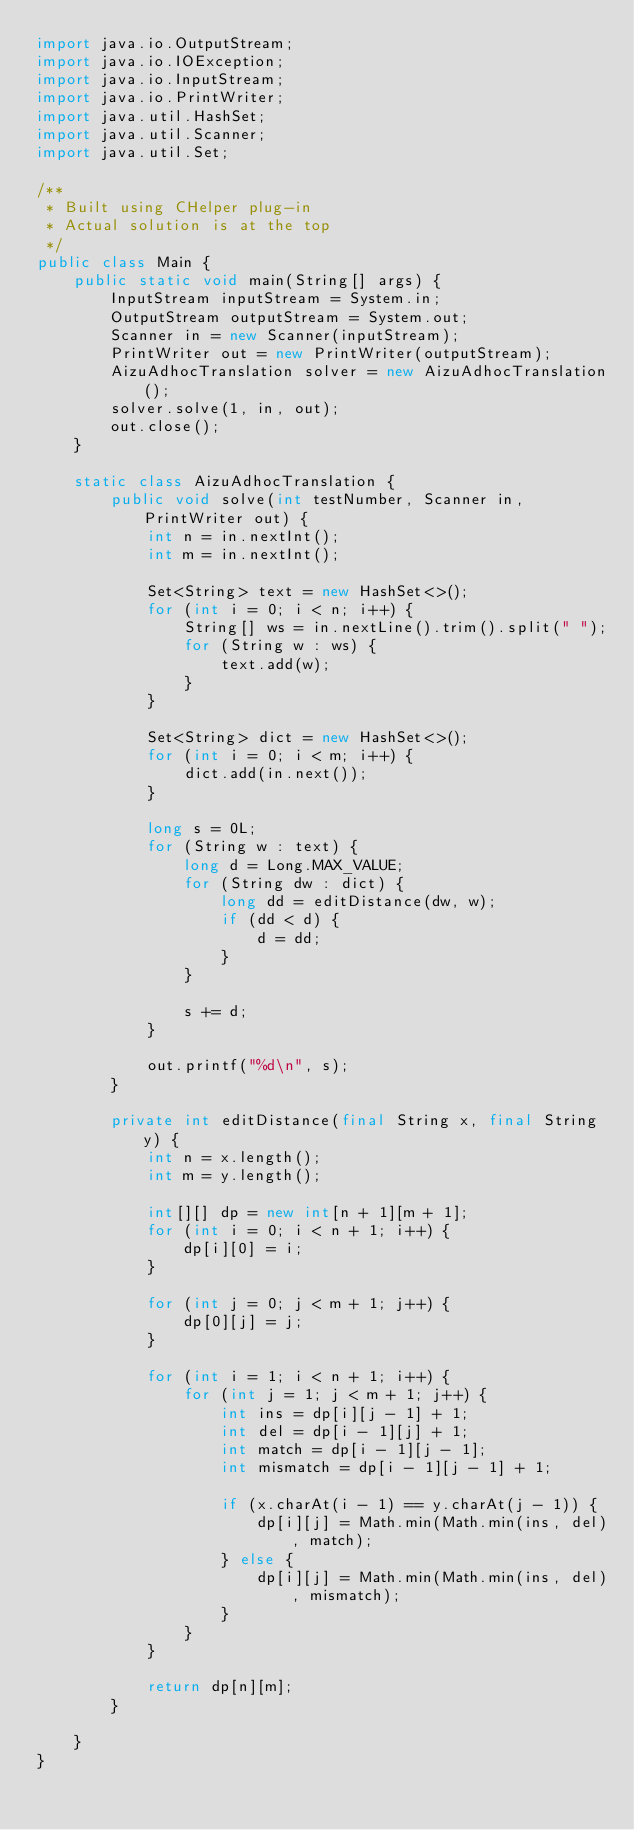Convert code to text. <code><loc_0><loc_0><loc_500><loc_500><_Java_>import java.io.OutputStream;
import java.io.IOException;
import java.io.InputStream;
import java.io.PrintWriter;
import java.util.HashSet;
import java.util.Scanner;
import java.util.Set;

/**
 * Built using CHelper plug-in
 * Actual solution is at the top
 */
public class Main {
    public static void main(String[] args) {
        InputStream inputStream = System.in;
        OutputStream outputStream = System.out;
        Scanner in = new Scanner(inputStream);
        PrintWriter out = new PrintWriter(outputStream);
        AizuAdhocTranslation solver = new AizuAdhocTranslation();
        solver.solve(1, in, out);
        out.close();
    }

    static class AizuAdhocTranslation {
        public void solve(int testNumber, Scanner in, PrintWriter out) {
            int n = in.nextInt();
            int m = in.nextInt();

            Set<String> text = new HashSet<>();
            for (int i = 0; i < n; i++) {
                String[] ws = in.nextLine().trim().split(" ");
                for (String w : ws) {
                    text.add(w);
                }
            }

            Set<String> dict = new HashSet<>();
            for (int i = 0; i < m; i++) {
                dict.add(in.next());
            }

            long s = 0L;
            for (String w : text) {
                long d = Long.MAX_VALUE;
                for (String dw : dict) {
                    long dd = editDistance(dw, w);
                    if (dd < d) {
                        d = dd;
                    }
                }

                s += d;
            }

            out.printf("%d\n", s);
        }

        private int editDistance(final String x, final String y) {
            int n = x.length();
            int m = y.length();

            int[][] dp = new int[n + 1][m + 1];
            for (int i = 0; i < n + 1; i++) {
                dp[i][0] = i;
            }

            for (int j = 0; j < m + 1; j++) {
                dp[0][j] = j;
            }

            for (int i = 1; i < n + 1; i++) {
                for (int j = 1; j < m + 1; j++) {
                    int ins = dp[i][j - 1] + 1;
                    int del = dp[i - 1][j] + 1;
                    int match = dp[i - 1][j - 1];
                    int mismatch = dp[i - 1][j - 1] + 1;

                    if (x.charAt(i - 1) == y.charAt(j - 1)) {
                        dp[i][j] = Math.min(Math.min(ins, del), match);
                    } else {
                        dp[i][j] = Math.min(Math.min(ins, del), mismatch);
                    }
                }
            }

            return dp[n][m];
        }

    }
}


</code> 